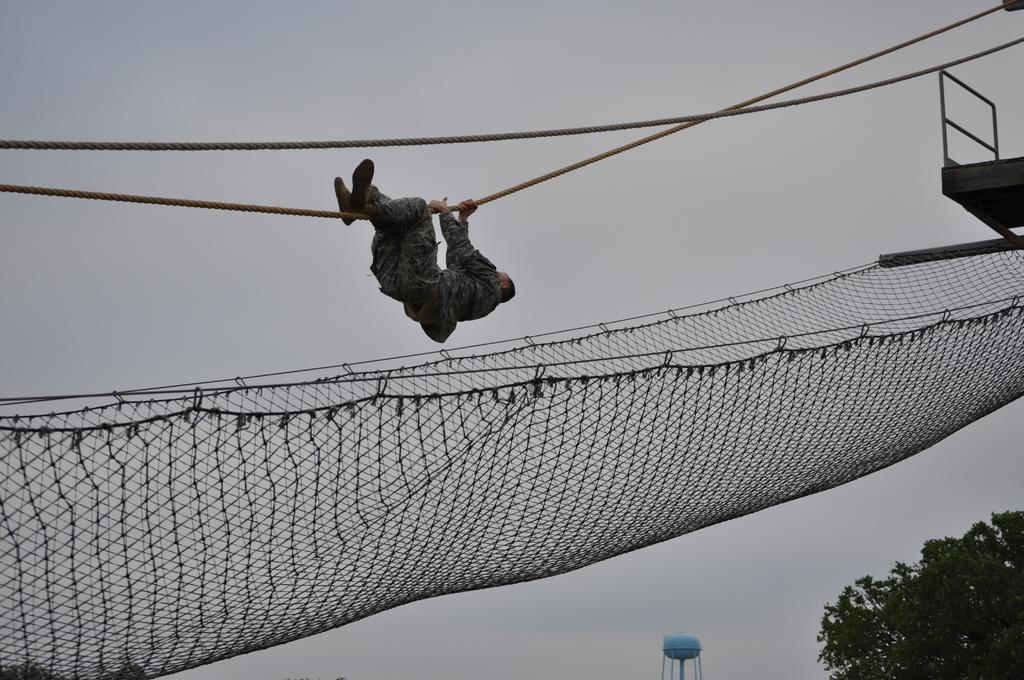What is the main subject of the image? There is a man in the image. What is the man doing in the image? The man is sliding with the help of a rope. What can be seen at the bottom of the image? There is a net, a tank, and a tree at the bottom of the image. What is visible in the background of the image? The sky is visible in the background of the image. What type of jellyfish can be seen swimming in the tank at the bottom of the image? There is no jellyfish present in the image; the tank is empty. What is the condition of the property in the image? There is no property mentioned in the image, so it is not possible to determine its condition. 